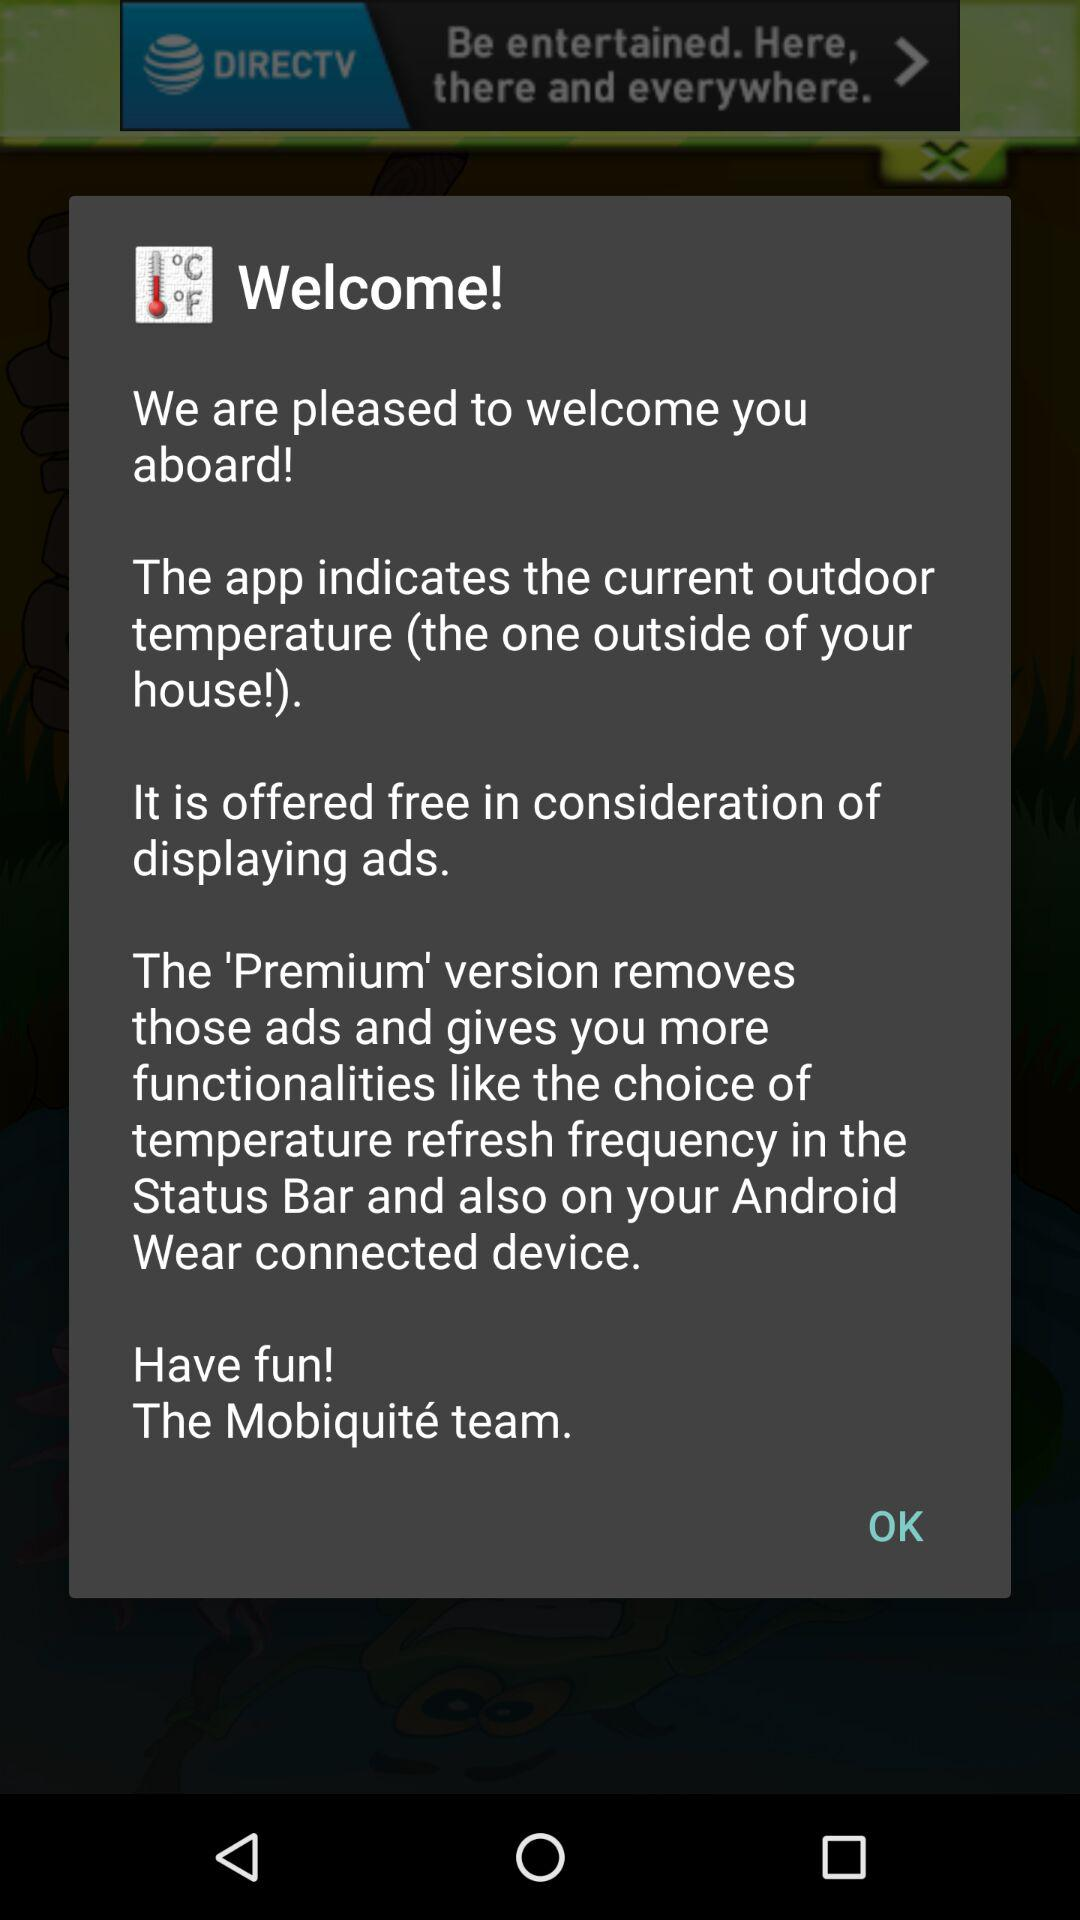How many lines of text are there in the app introduction?
Answer the question using a single word or phrase. 6 